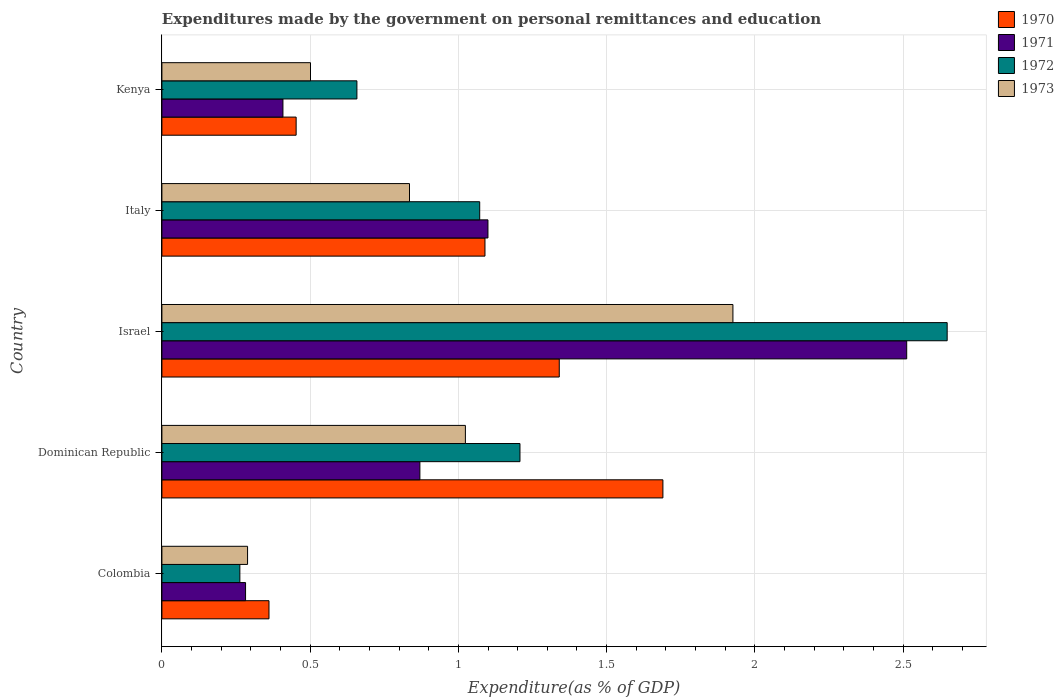Are the number of bars per tick equal to the number of legend labels?
Your response must be concise. Yes. Are the number of bars on each tick of the Y-axis equal?
Your answer should be very brief. Yes. How many bars are there on the 3rd tick from the bottom?
Your answer should be very brief. 4. In how many cases, is the number of bars for a given country not equal to the number of legend labels?
Your answer should be compact. 0. What is the expenditures made by the government on personal remittances and education in 1970 in Kenya?
Your response must be concise. 0.45. Across all countries, what is the maximum expenditures made by the government on personal remittances and education in 1973?
Make the answer very short. 1.93. Across all countries, what is the minimum expenditures made by the government on personal remittances and education in 1970?
Your answer should be very brief. 0.36. In which country was the expenditures made by the government on personal remittances and education in 1973 maximum?
Your response must be concise. Israel. In which country was the expenditures made by the government on personal remittances and education in 1970 minimum?
Your answer should be compact. Colombia. What is the total expenditures made by the government on personal remittances and education in 1972 in the graph?
Provide a short and direct response. 5.85. What is the difference between the expenditures made by the government on personal remittances and education in 1972 in Israel and that in Italy?
Give a very brief answer. 1.58. What is the difference between the expenditures made by the government on personal remittances and education in 1973 in Dominican Republic and the expenditures made by the government on personal remittances and education in 1971 in Kenya?
Provide a short and direct response. 0.62. What is the average expenditures made by the government on personal remittances and education in 1971 per country?
Offer a terse response. 1.03. What is the difference between the expenditures made by the government on personal remittances and education in 1970 and expenditures made by the government on personal remittances and education in 1972 in Dominican Republic?
Keep it short and to the point. 0.48. In how many countries, is the expenditures made by the government on personal remittances and education in 1972 greater than 0.30000000000000004 %?
Provide a succinct answer. 4. What is the ratio of the expenditures made by the government on personal remittances and education in 1973 in Dominican Republic to that in Italy?
Offer a terse response. 1.23. Is the expenditures made by the government on personal remittances and education in 1970 in Italy less than that in Kenya?
Provide a short and direct response. No. Is the difference between the expenditures made by the government on personal remittances and education in 1970 in Dominican Republic and Italy greater than the difference between the expenditures made by the government on personal remittances and education in 1972 in Dominican Republic and Italy?
Give a very brief answer. Yes. What is the difference between the highest and the second highest expenditures made by the government on personal remittances and education in 1973?
Your answer should be compact. 0.9. What is the difference between the highest and the lowest expenditures made by the government on personal remittances and education in 1970?
Your response must be concise. 1.33. Is the sum of the expenditures made by the government on personal remittances and education in 1972 in Colombia and Dominican Republic greater than the maximum expenditures made by the government on personal remittances and education in 1970 across all countries?
Offer a terse response. No. What does the 3rd bar from the top in Israel represents?
Your answer should be compact. 1971. Is it the case that in every country, the sum of the expenditures made by the government on personal remittances and education in 1970 and expenditures made by the government on personal remittances and education in 1973 is greater than the expenditures made by the government on personal remittances and education in 1971?
Offer a terse response. Yes. What is the difference between two consecutive major ticks on the X-axis?
Provide a short and direct response. 0.5. Are the values on the major ticks of X-axis written in scientific E-notation?
Provide a short and direct response. No. What is the title of the graph?
Offer a terse response. Expenditures made by the government on personal remittances and education. What is the label or title of the X-axis?
Provide a succinct answer. Expenditure(as % of GDP). What is the label or title of the Y-axis?
Provide a succinct answer. Country. What is the Expenditure(as % of GDP) in 1970 in Colombia?
Offer a terse response. 0.36. What is the Expenditure(as % of GDP) in 1971 in Colombia?
Offer a terse response. 0.28. What is the Expenditure(as % of GDP) in 1972 in Colombia?
Keep it short and to the point. 0.26. What is the Expenditure(as % of GDP) in 1973 in Colombia?
Make the answer very short. 0.29. What is the Expenditure(as % of GDP) in 1970 in Dominican Republic?
Your answer should be very brief. 1.69. What is the Expenditure(as % of GDP) in 1971 in Dominican Republic?
Make the answer very short. 0.87. What is the Expenditure(as % of GDP) in 1972 in Dominican Republic?
Your answer should be very brief. 1.21. What is the Expenditure(as % of GDP) of 1973 in Dominican Republic?
Provide a succinct answer. 1.02. What is the Expenditure(as % of GDP) of 1970 in Israel?
Offer a terse response. 1.34. What is the Expenditure(as % of GDP) in 1971 in Israel?
Make the answer very short. 2.51. What is the Expenditure(as % of GDP) in 1972 in Israel?
Provide a succinct answer. 2.65. What is the Expenditure(as % of GDP) of 1973 in Israel?
Your answer should be compact. 1.93. What is the Expenditure(as % of GDP) in 1970 in Italy?
Keep it short and to the point. 1.09. What is the Expenditure(as % of GDP) in 1971 in Italy?
Make the answer very short. 1.1. What is the Expenditure(as % of GDP) in 1972 in Italy?
Your answer should be very brief. 1.07. What is the Expenditure(as % of GDP) of 1973 in Italy?
Your answer should be compact. 0.84. What is the Expenditure(as % of GDP) of 1970 in Kenya?
Offer a terse response. 0.45. What is the Expenditure(as % of GDP) of 1971 in Kenya?
Your answer should be compact. 0.41. What is the Expenditure(as % of GDP) of 1972 in Kenya?
Provide a succinct answer. 0.66. What is the Expenditure(as % of GDP) in 1973 in Kenya?
Provide a succinct answer. 0.5. Across all countries, what is the maximum Expenditure(as % of GDP) in 1970?
Offer a very short reply. 1.69. Across all countries, what is the maximum Expenditure(as % of GDP) in 1971?
Your response must be concise. 2.51. Across all countries, what is the maximum Expenditure(as % of GDP) of 1972?
Offer a terse response. 2.65. Across all countries, what is the maximum Expenditure(as % of GDP) of 1973?
Keep it short and to the point. 1.93. Across all countries, what is the minimum Expenditure(as % of GDP) of 1970?
Offer a very short reply. 0.36. Across all countries, what is the minimum Expenditure(as % of GDP) in 1971?
Keep it short and to the point. 0.28. Across all countries, what is the minimum Expenditure(as % of GDP) in 1972?
Your response must be concise. 0.26. Across all countries, what is the minimum Expenditure(as % of GDP) in 1973?
Ensure brevity in your answer.  0.29. What is the total Expenditure(as % of GDP) of 1970 in the graph?
Your answer should be compact. 4.93. What is the total Expenditure(as % of GDP) of 1971 in the graph?
Your answer should be compact. 5.17. What is the total Expenditure(as % of GDP) in 1972 in the graph?
Give a very brief answer. 5.85. What is the total Expenditure(as % of GDP) of 1973 in the graph?
Keep it short and to the point. 4.57. What is the difference between the Expenditure(as % of GDP) of 1970 in Colombia and that in Dominican Republic?
Provide a succinct answer. -1.33. What is the difference between the Expenditure(as % of GDP) of 1971 in Colombia and that in Dominican Republic?
Provide a succinct answer. -0.59. What is the difference between the Expenditure(as % of GDP) in 1972 in Colombia and that in Dominican Republic?
Ensure brevity in your answer.  -0.94. What is the difference between the Expenditure(as % of GDP) of 1973 in Colombia and that in Dominican Republic?
Provide a short and direct response. -0.73. What is the difference between the Expenditure(as % of GDP) in 1970 in Colombia and that in Israel?
Provide a short and direct response. -0.98. What is the difference between the Expenditure(as % of GDP) of 1971 in Colombia and that in Israel?
Your answer should be very brief. -2.23. What is the difference between the Expenditure(as % of GDP) of 1972 in Colombia and that in Israel?
Provide a succinct answer. -2.39. What is the difference between the Expenditure(as % of GDP) of 1973 in Colombia and that in Israel?
Make the answer very short. -1.64. What is the difference between the Expenditure(as % of GDP) in 1970 in Colombia and that in Italy?
Your answer should be compact. -0.73. What is the difference between the Expenditure(as % of GDP) in 1971 in Colombia and that in Italy?
Your response must be concise. -0.82. What is the difference between the Expenditure(as % of GDP) in 1972 in Colombia and that in Italy?
Give a very brief answer. -0.81. What is the difference between the Expenditure(as % of GDP) of 1973 in Colombia and that in Italy?
Your answer should be compact. -0.55. What is the difference between the Expenditure(as % of GDP) in 1970 in Colombia and that in Kenya?
Ensure brevity in your answer.  -0.09. What is the difference between the Expenditure(as % of GDP) in 1971 in Colombia and that in Kenya?
Make the answer very short. -0.13. What is the difference between the Expenditure(as % of GDP) of 1972 in Colombia and that in Kenya?
Your response must be concise. -0.39. What is the difference between the Expenditure(as % of GDP) in 1973 in Colombia and that in Kenya?
Provide a short and direct response. -0.21. What is the difference between the Expenditure(as % of GDP) in 1970 in Dominican Republic and that in Israel?
Offer a terse response. 0.35. What is the difference between the Expenditure(as % of GDP) of 1971 in Dominican Republic and that in Israel?
Keep it short and to the point. -1.64. What is the difference between the Expenditure(as % of GDP) in 1972 in Dominican Republic and that in Israel?
Give a very brief answer. -1.44. What is the difference between the Expenditure(as % of GDP) in 1973 in Dominican Republic and that in Israel?
Keep it short and to the point. -0.9. What is the difference between the Expenditure(as % of GDP) in 1970 in Dominican Republic and that in Italy?
Offer a terse response. 0.6. What is the difference between the Expenditure(as % of GDP) in 1971 in Dominican Republic and that in Italy?
Give a very brief answer. -0.23. What is the difference between the Expenditure(as % of GDP) of 1972 in Dominican Republic and that in Italy?
Your response must be concise. 0.14. What is the difference between the Expenditure(as % of GDP) of 1973 in Dominican Republic and that in Italy?
Give a very brief answer. 0.19. What is the difference between the Expenditure(as % of GDP) of 1970 in Dominican Republic and that in Kenya?
Offer a terse response. 1.24. What is the difference between the Expenditure(as % of GDP) of 1971 in Dominican Republic and that in Kenya?
Your response must be concise. 0.46. What is the difference between the Expenditure(as % of GDP) of 1972 in Dominican Republic and that in Kenya?
Keep it short and to the point. 0.55. What is the difference between the Expenditure(as % of GDP) of 1973 in Dominican Republic and that in Kenya?
Your answer should be compact. 0.52. What is the difference between the Expenditure(as % of GDP) in 1970 in Israel and that in Italy?
Your answer should be compact. 0.25. What is the difference between the Expenditure(as % of GDP) in 1971 in Israel and that in Italy?
Provide a short and direct response. 1.41. What is the difference between the Expenditure(as % of GDP) in 1972 in Israel and that in Italy?
Offer a terse response. 1.58. What is the difference between the Expenditure(as % of GDP) of 1973 in Israel and that in Italy?
Make the answer very short. 1.09. What is the difference between the Expenditure(as % of GDP) in 1970 in Israel and that in Kenya?
Provide a short and direct response. 0.89. What is the difference between the Expenditure(as % of GDP) in 1971 in Israel and that in Kenya?
Offer a very short reply. 2.1. What is the difference between the Expenditure(as % of GDP) of 1972 in Israel and that in Kenya?
Your answer should be compact. 1.99. What is the difference between the Expenditure(as % of GDP) of 1973 in Israel and that in Kenya?
Keep it short and to the point. 1.42. What is the difference between the Expenditure(as % of GDP) of 1970 in Italy and that in Kenya?
Ensure brevity in your answer.  0.64. What is the difference between the Expenditure(as % of GDP) of 1971 in Italy and that in Kenya?
Offer a terse response. 0.69. What is the difference between the Expenditure(as % of GDP) in 1972 in Italy and that in Kenya?
Make the answer very short. 0.41. What is the difference between the Expenditure(as % of GDP) of 1973 in Italy and that in Kenya?
Provide a succinct answer. 0.33. What is the difference between the Expenditure(as % of GDP) in 1970 in Colombia and the Expenditure(as % of GDP) in 1971 in Dominican Republic?
Ensure brevity in your answer.  -0.51. What is the difference between the Expenditure(as % of GDP) of 1970 in Colombia and the Expenditure(as % of GDP) of 1972 in Dominican Republic?
Your answer should be compact. -0.85. What is the difference between the Expenditure(as % of GDP) of 1970 in Colombia and the Expenditure(as % of GDP) of 1973 in Dominican Republic?
Offer a very short reply. -0.66. What is the difference between the Expenditure(as % of GDP) of 1971 in Colombia and the Expenditure(as % of GDP) of 1972 in Dominican Republic?
Offer a terse response. -0.93. What is the difference between the Expenditure(as % of GDP) in 1971 in Colombia and the Expenditure(as % of GDP) in 1973 in Dominican Republic?
Offer a very short reply. -0.74. What is the difference between the Expenditure(as % of GDP) of 1972 in Colombia and the Expenditure(as % of GDP) of 1973 in Dominican Republic?
Your answer should be compact. -0.76. What is the difference between the Expenditure(as % of GDP) of 1970 in Colombia and the Expenditure(as % of GDP) of 1971 in Israel?
Give a very brief answer. -2.15. What is the difference between the Expenditure(as % of GDP) of 1970 in Colombia and the Expenditure(as % of GDP) of 1972 in Israel?
Keep it short and to the point. -2.29. What is the difference between the Expenditure(as % of GDP) of 1970 in Colombia and the Expenditure(as % of GDP) of 1973 in Israel?
Offer a very short reply. -1.56. What is the difference between the Expenditure(as % of GDP) of 1971 in Colombia and the Expenditure(as % of GDP) of 1972 in Israel?
Your answer should be compact. -2.37. What is the difference between the Expenditure(as % of GDP) in 1971 in Colombia and the Expenditure(as % of GDP) in 1973 in Israel?
Your response must be concise. -1.64. What is the difference between the Expenditure(as % of GDP) in 1972 in Colombia and the Expenditure(as % of GDP) in 1973 in Israel?
Ensure brevity in your answer.  -1.66. What is the difference between the Expenditure(as % of GDP) in 1970 in Colombia and the Expenditure(as % of GDP) in 1971 in Italy?
Offer a terse response. -0.74. What is the difference between the Expenditure(as % of GDP) of 1970 in Colombia and the Expenditure(as % of GDP) of 1972 in Italy?
Provide a short and direct response. -0.71. What is the difference between the Expenditure(as % of GDP) in 1970 in Colombia and the Expenditure(as % of GDP) in 1973 in Italy?
Keep it short and to the point. -0.47. What is the difference between the Expenditure(as % of GDP) in 1971 in Colombia and the Expenditure(as % of GDP) in 1972 in Italy?
Your answer should be very brief. -0.79. What is the difference between the Expenditure(as % of GDP) of 1971 in Colombia and the Expenditure(as % of GDP) of 1973 in Italy?
Provide a short and direct response. -0.55. What is the difference between the Expenditure(as % of GDP) of 1972 in Colombia and the Expenditure(as % of GDP) of 1973 in Italy?
Your response must be concise. -0.57. What is the difference between the Expenditure(as % of GDP) in 1970 in Colombia and the Expenditure(as % of GDP) in 1971 in Kenya?
Provide a short and direct response. -0.05. What is the difference between the Expenditure(as % of GDP) of 1970 in Colombia and the Expenditure(as % of GDP) of 1972 in Kenya?
Keep it short and to the point. -0.3. What is the difference between the Expenditure(as % of GDP) of 1970 in Colombia and the Expenditure(as % of GDP) of 1973 in Kenya?
Your answer should be compact. -0.14. What is the difference between the Expenditure(as % of GDP) in 1971 in Colombia and the Expenditure(as % of GDP) in 1972 in Kenya?
Keep it short and to the point. -0.38. What is the difference between the Expenditure(as % of GDP) in 1971 in Colombia and the Expenditure(as % of GDP) in 1973 in Kenya?
Give a very brief answer. -0.22. What is the difference between the Expenditure(as % of GDP) of 1972 in Colombia and the Expenditure(as % of GDP) of 1973 in Kenya?
Keep it short and to the point. -0.24. What is the difference between the Expenditure(as % of GDP) of 1970 in Dominican Republic and the Expenditure(as % of GDP) of 1971 in Israel?
Offer a very short reply. -0.82. What is the difference between the Expenditure(as % of GDP) of 1970 in Dominican Republic and the Expenditure(as % of GDP) of 1972 in Israel?
Provide a short and direct response. -0.96. What is the difference between the Expenditure(as % of GDP) of 1970 in Dominican Republic and the Expenditure(as % of GDP) of 1973 in Israel?
Provide a succinct answer. -0.24. What is the difference between the Expenditure(as % of GDP) of 1971 in Dominican Republic and the Expenditure(as % of GDP) of 1972 in Israel?
Give a very brief answer. -1.78. What is the difference between the Expenditure(as % of GDP) in 1971 in Dominican Republic and the Expenditure(as % of GDP) in 1973 in Israel?
Your answer should be very brief. -1.06. What is the difference between the Expenditure(as % of GDP) in 1972 in Dominican Republic and the Expenditure(as % of GDP) in 1973 in Israel?
Your answer should be compact. -0.72. What is the difference between the Expenditure(as % of GDP) in 1970 in Dominican Republic and the Expenditure(as % of GDP) in 1971 in Italy?
Offer a terse response. 0.59. What is the difference between the Expenditure(as % of GDP) in 1970 in Dominican Republic and the Expenditure(as % of GDP) in 1972 in Italy?
Ensure brevity in your answer.  0.62. What is the difference between the Expenditure(as % of GDP) of 1970 in Dominican Republic and the Expenditure(as % of GDP) of 1973 in Italy?
Offer a terse response. 0.85. What is the difference between the Expenditure(as % of GDP) of 1971 in Dominican Republic and the Expenditure(as % of GDP) of 1972 in Italy?
Make the answer very short. -0.2. What is the difference between the Expenditure(as % of GDP) in 1971 in Dominican Republic and the Expenditure(as % of GDP) in 1973 in Italy?
Make the answer very short. 0.04. What is the difference between the Expenditure(as % of GDP) of 1972 in Dominican Republic and the Expenditure(as % of GDP) of 1973 in Italy?
Make the answer very short. 0.37. What is the difference between the Expenditure(as % of GDP) of 1970 in Dominican Republic and the Expenditure(as % of GDP) of 1971 in Kenya?
Your answer should be very brief. 1.28. What is the difference between the Expenditure(as % of GDP) in 1970 in Dominican Republic and the Expenditure(as % of GDP) in 1972 in Kenya?
Give a very brief answer. 1.03. What is the difference between the Expenditure(as % of GDP) in 1970 in Dominican Republic and the Expenditure(as % of GDP) in 1973 in Kenya?
Your answer should be very brief. 1.19. What is the difference between the Expenditure(as % of GDP) in 1971 in Dominican Republic and the Expenditure(as % of GDP) in 1972 in Kenya?
Offer a very short reply. 0.21. What is the difference between the Expenditure(as % of GDP) in 1971 in Dominican Republic and the Expenditure(as % of GDP) in 1973 in Kenya?
Your response must be concise. 0.37. What is the difference between the Expenditure(as % of GDP) in 1972 in Dominican Republic and the Expenditure(as % of GDP) in 1973 in Kenya?
Offer a very short reply. 0.71. What is the difference between the Expenditure(as % of GDP) of 1970 in Israel and the Expenditure(as % of GDP) of 1971 in Italy?
Ensure brevity in your answer.  0.24. What is the difference between the Expenditure(as % of GDP) in 1970 in Israel and the Expenditure(as % of GDP) in 1972 in Italy?
Offer a very short reply. 0.27. What is the difference between the Expenditure(as % of GDP) of 1970 in Israel and the Expenditure(as % of GDP) of 1973 in Italy?
Provide a succinct answer. 0.51. What is the difference between the Expenditure(as % of GDP) of 1971 in Israel and the Expenditure(as % of GDP) of 1972 in Italy?
Make the answer very short. 1.44. What is the difference between the Expenditure(as % of GDP) in 1971 in Israel and the Expenditure(as % of GDP) in 1973 in Italy?
Keep it short and to the point. 1.68. What is the difference between the Expenditure(as % of GDP) of 1972 in Israel and the Expenditure(as % of GDP) of 1973 in Italy?
Your answer should be very brief. 1.81. What is the difference between the Expenditure(as % of GDP) in 1970 in Israel and the Expenditure(as % of GDP) in 1971 in Kenya?
Provide a succinct answer. 0.93. What is the difference between the Expenditure(as % of GDP) of 1970 in Israel and the Expenditure(as % of GDP) of 1972 in Kenya?
Offer a terse response. 0.68. What is the difference between the Expenditure(as % of GDP) in 1970 in Israel and the Expenditure(as % of GDP) in 1973 in Kenya?
Offer a very short reply. 0.84. What is the difference between the Expenditure(as % of GDP) in 1971 in Israel and the Expenditure(as % of GDP) in 1972 in Kenya?
Ensure brevity in your answer.  1.85. What is the difference between the Expenditure(as % of GDP) in 1971 in Israel and the Expenditure(as % of GDP) in 1973 in Kenya?
Offer a terse response. 2.01. What is the difference between the Expenditure(as % of GDP) in 1972 in Israel and the Expenditure(as % of GDP) in 1973 in Kenya?
Give a very brief answer. 2.15. What is the difference between the Expenditure(as % of GDP) in 1970 in Italy and the Expenditure(as % of GDP) in 1971 in Kenya?
Ensure brevity in your answer.  0.68. What is the difference between the Expenditure(as % of GDP) of 1970 in Italy and the Expenditure(as % of GDP) of 1972 in Kenya?
Make the answer very short. 0.43. What is the difference between the Expenditure(as % of GDP) of 1970 in Italy and the Expenditure(as % of GDP) of 1973 in Kenya?
Make the answer very short. 0.59. What is the difference between the Expenditure(as % of GDP) of 1971 in Italy and the Expenditure(as % of GDP) of 1972 in Kenya?
Your answer should be very brief. 0.44. What is the difference between the Expenditure(as % of GDP) in 1971 in Italy and the Expenditure(as % of GDP) in 1973 in Kenya?
Provide a succinct answer. 0.6. What is the difference between the Expenditure(as % of GDP) of 1972 in Italy and the Expenditure(as % of GDP) of 1973 in Kenya?
Provide a short and direct response. 0.57. What is the average Expenditure(as % of GDP) in 1970 per country?
Your response must be concise. 0.99. What is the average Expenditure(as % of GDP) in 1971 per country?
Make the answer very short. 1.03. What is the average Expenditure(as % of GDP) in 1972 per country?
Make the answer very short. 1.17. What is the average Expenditure(as % of GDP) in 1973 per country?
Give a very brief answer. 0.91. What is the difference between the Expenditure(as % of GDP) of 1970 and Expenditure(as % of GDP) of 1971 in Colombia?
Offer a terse response. 0.08. What is the difference between the Expenditure(as % of GDP) in 1970 and Expenditure(as % of GDP) in 1972 in Colombia?
Provide a succinct answer. 0.1. What is the difference between the Expenditure(as % of GDP) in 1970 and Expenditure(as % of GDP) in 1973 in Colombia?
Provide a succinct answer. 0.07. What is the difference between the Expenditure(as % of GDP) of 1971 and Expenditure(as % of GDP) of 1972 in Colombia?
Ensure brevity in your answer.  0.02. What is the difference between the Expenditure(as % of GDP) in 1971 and Expenditure(as % of GDP) in 1973 in Colombia?
Your answer should be compact. -0.01. What is the difference between the Expenditure(as % of GDP) in 1972 and Expenditure(as % of GDP) in 1973 in Colombia?
Offer a very short reply. -0.03. What is the difference between the Expenditure(as % of GDP) of 1970 and Expenditure(as % of GDP) of 1971 in Dominican Republic?
Ensure brevity in your answer.  0.82. What is the difference between the Expenditure(as % of GDP) of 1970 and Expenditure(as % of GDP) of 1972 in Dominican Republic?
Offer a terse response. 0.48. What is the difference between the Expenditure(as % of GDP) of 1970 and Expenditure(as % of GDP) of 1973 in Dominican Republic?
Offer a terse response. 0.67. What is the difference between the Expenditure(as % of GDP) in 1971 and Expenditure(as % of GDP) in 1972 in Dominican Republic?
Keep it short and to the point. -0.34. What is the difference between the Expenditure(as % of GDP) of 1971 and Expenditure(as % of GDP) of 1973 in Dominican Republic?
Give a very brief answer. -0.15. What is the difference between the Expenditure(as % of GDP) in 1972 and Expenditure(as % of GDP) in 1973 in Dominican Republic?
Keep it short and to the point. 0.18. What is the difference between the Expenditure(as % of GDP) in 1970 and Expenditure(as % of GDP) in 1971 in Israel?
Make the answer very short. -1.17. What is the difference between the Expenditure(as % of GDP) of 1970 and Expenditure(as % of GDP) of 1972 in Israel?
Your answer should be compact. -1.31. What is the difference between the Expenditure(as % of GDP) in 1970 and Expenditure(as % of GDP) in 1973 in Israel?
Offer a terse response. -0.59. What is the difference between the Expenditure(as % of GDP) in 1971 and Expenditure(as % of GDP) in 1972 in Israel?
Provide a short and direct response. -0.14. What is the difference between the Expenditure(as % of GDP) of 1971 and Expenditure(as % of GDP) of 1973 in Israel?
Ensure brevity in your answer.  0.59. What is the difference between the Expenditure(as % of GDP) of 1972 and Expenditure(as % of GDP) of 1973 in Israel?
Give a very brief answer. 0.72. What is the difference between the Expenditure(as % of GDP) of 1970 and Expenditure(as % of GDP) of 1971 in Italy?
Give a very brief answer. -0.01. What is the difference between the Expenditure(as % of GDP) of 1970 and Expenditure(as % of GDP) of 1972 in Italy?
Provide a succinct answer. 0.02. What is the difference between the Expenditure(as % of GDP) in 1970 and Expenditure(as % of GDP) in 1973 in Italy?
Provide a short and direct response. 0.25. What is the difference between the Expenditure(as % of GDP) of 1971 and Expenditure(as % of GDP) of 1972 in Italy?
Make the answer very short. 0.03. What is the difference between the Expenditure(as % of GDP) in 1971 and Expenditure(as % of GDP) in 1973 in Italy?
Provide a short and direct response. 0.26. What is the difference between the Expenditure(as % of GDP) of 1972 and Expenditure(as % of GDP) of 1973 in Italy?
Your response must be concise. 0.24. What is the difference between the Expenditure(as % of GDP) of 1970 and Expenditure(as % of GDP) of 1971 in Kenya?
Offer a very short reply. 0.04. What is the difference between the Expenditure(as % of GDP) of 1970 and Expenditure(as % of GDP) of 1972 in Kenya?
Give a very brief answer. -0.2. What is the difference between the Expenditure(as % of GDP) of 1970 and Expenditure(as % of GDP) of 1973 in Kenya?
Your response must be concise. -0.05. What is the difference between the Expenditure(as % of GDP) in 1971 and Expenditure(as % of GDP) in 1972 in Kenya?
Keep it short and to the point. -0.25. What is the difference between the Expenditure(as % of GDP) in 1971 and Expenditure(as % of GDP) in 1973 in Kenya?
Keep it short and to the point. -0.09. What is the difference between the Expenditure(as % of GDP) in 1972 and Expenditure(as % of GDP) in 1973 in Kenya?
Ensure brevity in your answer.  0.16. What is the ratio of the Expenditure(as % of GDP) in 1970 in Colombia to that in Dominican Republic?
Your response must be concise. 0.21. What is the ratio of the Expenditure(as % of GDP) in 1971 in Colombia to that in Dominican Republic?
Give a very brief answer. 0.32. What is the ratio of the Expenditure(as % of GDP) in 1972 in Colombia to that in Dominican Republic?
Offer a terse response. 0.22. What is the ratio of the Expenditure(as % of GDP) in 1973 in Colombia to that in Dominican Republic?
Offer a terse response. 0.28. What is the ratio of the Expenditure(as % of GDP) of 1970 in Colombia to that in Israel?
Provide a short and direct response. 0.27. What is the ratio of the Expenditure(as % of GDP) of 1971 in Colombia to that in Israel?
Ensure brevity in your answer.  0.11. What is the ratio of the Expenditure(as % of GDP) of 1972 in Colombia to that in Israel?
Offer a terse response. 0.1. What is the ratio of the Expenditure(as % of GDP) in 1970 in Colombia to that in Italy?
Your response must be concise. 0.33. What is the ratio of the Expenditure(as % of GDP) of 1971 in Colombia to that in Italy?
Offer a terse response. 0.26. What is the ratio of the Expenditure(as % of GDP) in 1972 in Colombia to that in Italy?
Make the answer very short. 0.25. What is the ratio of the Expenditure(as % of GDP) of 1973 in Colombia to that in Italy?
Provide a succinct answer. 0.35. What is the ratio of the Expenditure(as % of GDP) of 1970 in Colombia to that in Kenya?
Your answer should be compact. 0.8. What is the ratio of the Expenditure(as % of GDP) in 1971 in Colombia to that in Kenya?
Give a very brief answer. 0.69. What is the ratio of the Expenditure(as % of GDP) in 1972 in Colombia to that in Kenya?
Ensure brevity in your answer.  0.4. What is the ratio of the Expenditure(as % of GDP) of 1973 in Colombia to that in Kenya?
Make the answer very short. 0.58. What is the ratio of the Expenditure(as % of GDP) in 1970 in Dominican Republic to that in Israel?
Keep it short and to the point. 1.26. What is the ratio of the Expenditure(as % of GDP) of 1971 in Dominican Republic to that in Israel?
Your answer should be compact. 0.35. What is the ratio of the Expenditure(as % of GDP) in 1972 in Dominican Republic to that in Israel?
Ensure brevity in your answer.  0.46. What is the ratio of the Expenditure(as % of GDP) in 1973 in Dominican Republic to that in Israel?
Offer a terse response. 0.53. What is the ratio of the Expenditure(as % of GDP) of 1970 in Dominican Republic to that in Italy?
Your response must be concise. 1.55. What is the ratio of the Expenditure(as % of GDP) of 1971 in Dominican Republic to that in Italy?
Ensure brevity in your answer.  0.79. What is the ratio of the Expenditure(as % of GDP) of 1972 in Dominican Republic to that in Italy?
Offer a very short reply. 1.13. What is the ratio of the Expenditure(as % of GDP) of 1973 in Dominican Republic to that in Italy?
Your answer should be compact. 1.23. What is the ratio of the Expenditure(as % of GDP) in 1970 in Dominican Republic to that in Kenya?
Make the answer very short. 3.73. What is the ratio of the Expenditure(as % of GDP) of 1971 in Dominican Republic to that in Kenya?
Provide a succinct answer. 2.13. What is the ratio of the Expenditure(as % of GDP) of 1972 in Dominican Republic to that in Kenya?
Your answer should be very brief. 1.84. What is the ratio of the Expenditure(as % of GDP) in 1973 in Dominican Republic to that in Kenya?
Keep it short and to the point. 2.04. What is the ratio of the Expenditure(as % of GDP) of 1970 in Israel to that in Italy?
Provide a succinct answer. 1.23. What is the ratio of the Expenditure(as % of GDP) of 1971 in Israel to that in Italy?
Provide a succinct answer. 2.28. What is the ratio of the Expenditure(as % of GDP) in 1972 in Israel to that in Italy?
Give a very brief answer. 2.47. What is the ratio of the Expenditure(as % of GDP) in 1973 in Israel to that in Italy?
Your response must be concise. 2.31. What is the ratio of the Expenditure(as % of GDP) in 1970 in Israel to that in Kenya?
Ensure brevity in your answer.  2.96. What is the ratio of the Expenditure(as % of GDP) in 1971 in Israel to that in Kenya?
Offer a terse response. 6.15. What is the ratio of the Expenditure(as % of GDP) in 1972 in Israel to that in Kenya?
Your answer should be very brief. 4.03. What is the ratio of the Expenditure(as % of GDP) in 1973 in Israel to that in Kenya?
Your response must be concise. 3.84. What is the ratio of the Expenditure(as % of GDP) in 1970 in Italy to that in Kenya?
Offer a very short reply. 2.41. What is the ratio of the Expenditure(as % of GDP) of 1971 in Italy to that in Kenya?
Your answer should be compact. 2.69. What is the ratio of the Expenditure(as % of GDP) in 1972 in Italy to that in Kenya?
Offer a terse response. 1.63. What is the ratio of the Expenditure(as % of GDP) of 1973 in Italy to that in Kenya?
Provide a short and direct response. 1.67. What is the difference between the highest and the second highest Expenditure(as % of GDP) in 1970?
Your answer should be compact. 0.35. What is the difference between the highest and the second highest Expenditure(as % of GDP) of 1971?
Your answer should be compact. 1.41. What is the difference between the highest and the second highest Expenditure(as % of GDP) of 1972?
Offer a terse response. 1.44. What is the difference between the highest and the second highest Expenditure(as % of GDP) of 1973?
Give a very brief answer. 0.9. What is the difference between the highest and the lowest Expenditure(as % of GDP) of 1970?
Give a very brief answer. 1.33. What is the difference between the highest and the lowest Expenditure(as % of GDP) of 1971?
Provide a succinct answer. 2.23. What is the difference between the highest and the lowest Expenditure(as % of GDP) of 1972?
Offer a terse response. 2.39. What is the difference between the highest and the lowest Expenditure(as % of GDP) in 1973?
Your response must be concise. 1.64. 